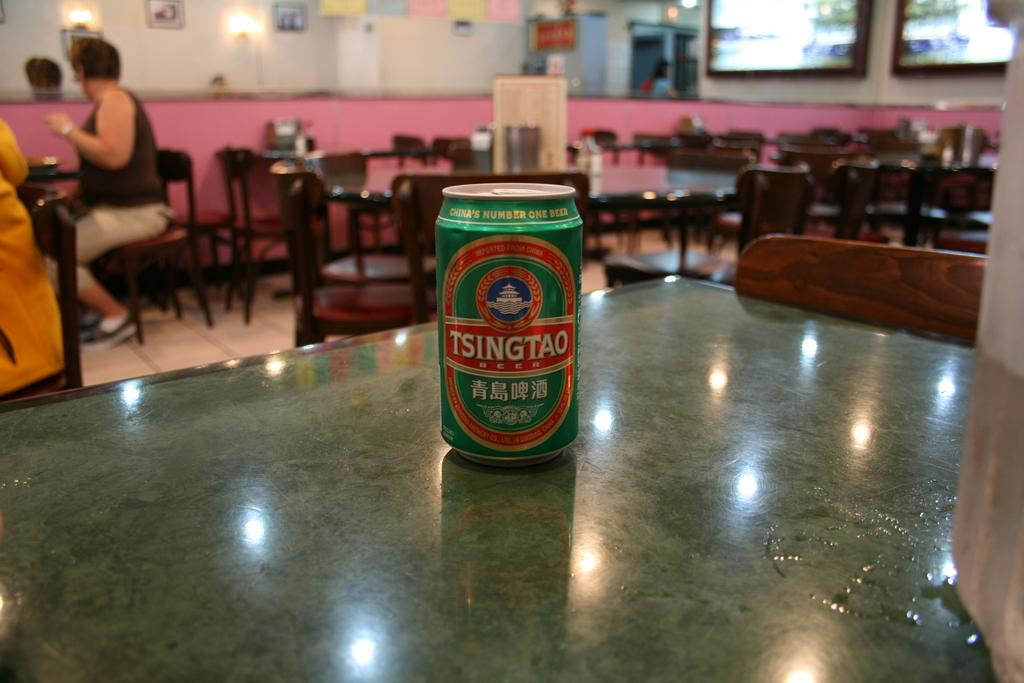<image>
Give a short and clear explanation of the subsequent image. A can of Tsingtao beer sits unopened on a table. 